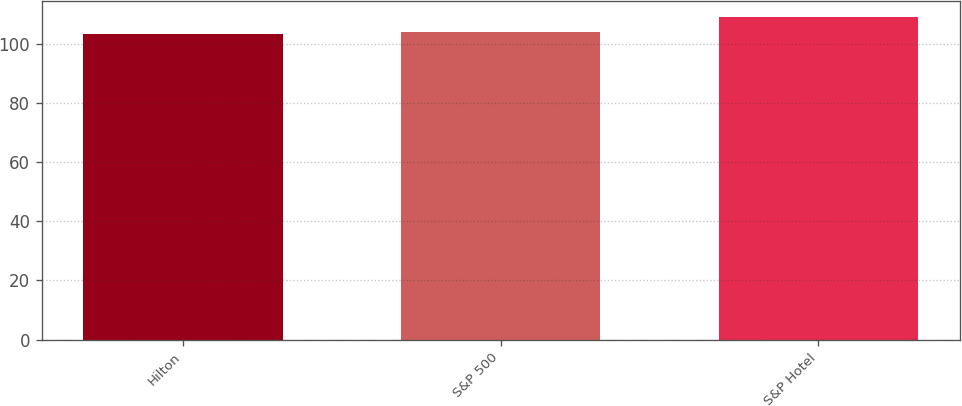Convert chart. <chart><loc_0><loc_0><loc_500><loc_500><bar_chart><fcel>Hilton<fcel>S&P 500<fcel>S&P Hotel<nl><fcel>103.49<fcel>104.1<fcel>109.17<nl></chart> 